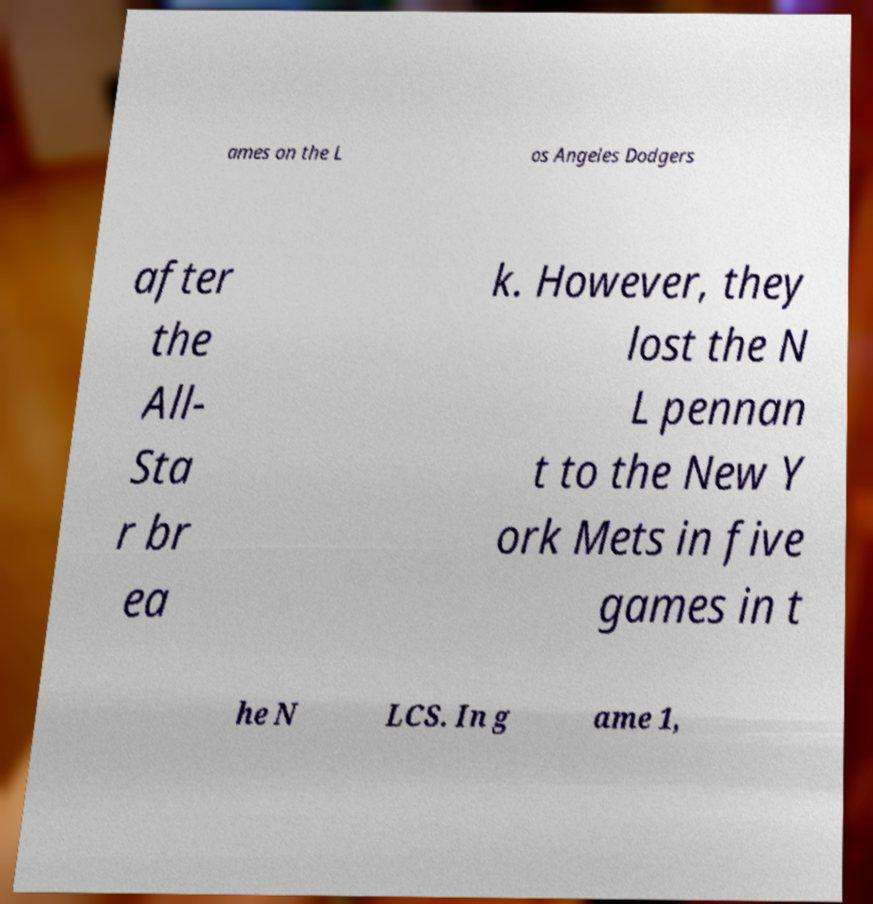Can you read and provide the text displayed in the image?This photo seems to have some interesting text. Can you extract and type it out for me? ames on the L os Angeles Dodgers after the All- Sta r br ea k. However, they lost the N L pennan t to the New Y ork Mets in five games in t he N LCS. In g ame 1, 